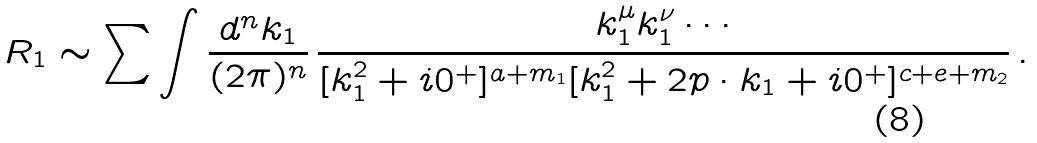Convert formula to latex. <formula><loc_0><loc_0><loc_500><loc_500>R _ { 1 } \sim \sum \int \frac { d ^ { n } k _ { 1 } } { ( 2 \pi ) ^ { n } } \, \frac { k _ { 1 } ^ { \mu } k _ { 1 } ^ { \nu } \cdots } { [ k _ { 1 } ^ { 2 } + i 0 ^ { + } ] ^ { a + m _ { 1 } } [ k _ { 1 } ^ { 2 } + 2 p \cdot k _ { 1 } + i 0 ^ { + } ] ^ { c + e + m _ { 2 } } } \, .</formula> 